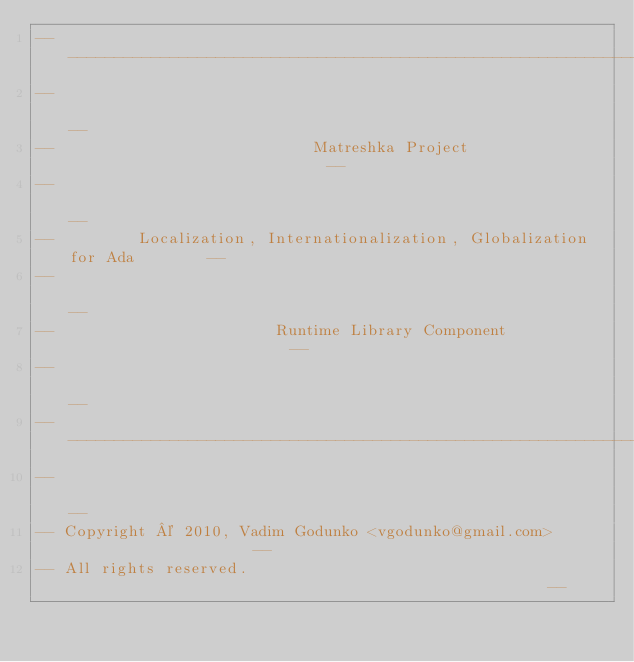Convert code to text. <code><loc_0><loc_0><loc_500><loc_500><_Ada_>------------------------------------------------------------------------------
--                                                                          --
--                            Matreshka Project                             --
--                                                                          --
--         Localization, Internationalization, Globalization for Ada        --
--                                                                          --
--                        Runtime Library Component                         --
--                                                                          --
------------------------------------------------------------------------------
--                                                                          --
-- Copyright © 2010, Vadim Godunko <vgodunko@gmail.com>                     --
-- All rights reserved.                                                     --</code> 